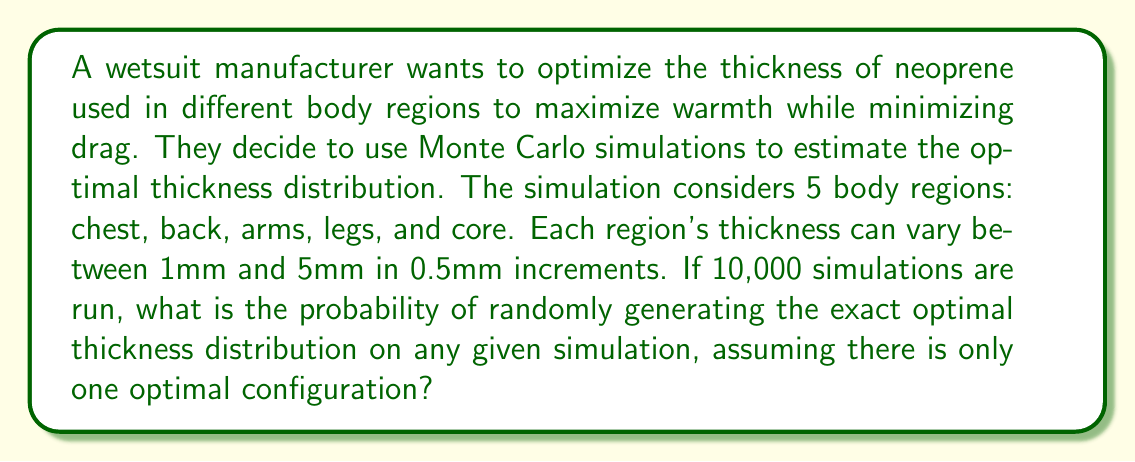Show me your answer to this math problem. To solve this problem, we need to follow these steps:

1. Calculate the number of possible thickness options for each body region:
   There are 9 options (1, 1.5, 2, 2.5, 3, 3.5, 4, 4.5, 5 mm) for each region.

2. Calculate the total number of possible configurations:
   With 5 body regions and 9 options for each, we have:
   $$\text{Total configurations} = 9^5 = 59,049$$

3. Calculate the probability of randomly generating the optimal configuration:
   The probability is 1 divided by the total number of configurations:
   $$P(\text{optimal}) = \frac{1}{59,049} \approx 0.0000169$$

4. Convert to percentage:
   $$P(\text{optimal}) \approx 0.00169\%$$

This extremely low probability demonstrates the value of using Monte Carlo simulations to search for optimal configurations, as randomly guessing would be highly inefficient.
Answer: $\frac{1}{59,049}$ or approximately 0.00169% 